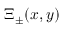Convert formula to latex. <formula><loc_0><loc_0><loc_500><loc_500>\Xi _ { \pm } ( x , y )</formula> 